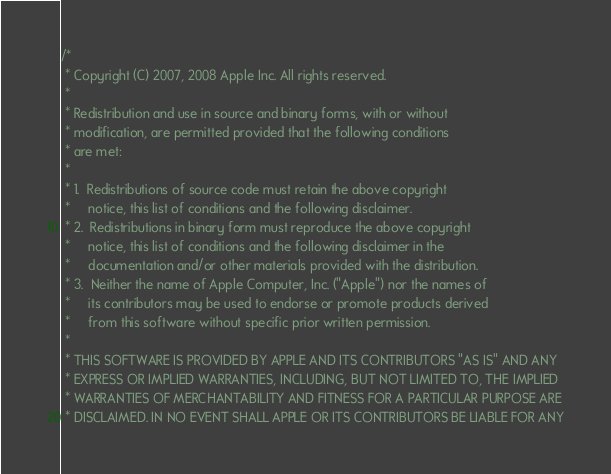<code> <loc_0><loc_0><loc_500><loc_500><_ObjectiveC_>/*
 * Copyright (C) 2007, 2008 Apple Inc. All rights reserved.
 *
 * Redistribution and use in source and binary forms, with or without
 * modification, are permitted provided that the following conditions
 * are met:
 *
 * 1.  Redistributions of source code must retain the above copyright
 *     notice, this list of conditions and the following disclaimer. 
 * 2.  Redistributions in binary form must reproduce the above copyright
 *     notice, this list of conditions and the following disclaimer in the
 *     documentation and/or other materials provided with the distribution. 
 * 3.  Neither the name of Apple Computer, Inc. ("Apple") nor the names of
 *     its contributors may be used to endorse or promote products derived
 *     from this software without specific prior written permission. 
 *
 * THIS SOFTWARE IS PROVIDED BY APPLE AND ITS CONTRIBUTORS "AS IS" AND ANY
 * EXPRESS OR IMPLIED WARRANTIES, INCLUDING, BUT NOT LIMITED TO, THE IMPLIED
 * WARRANTIES OF MERCHANTABILITY AND FITNESS FOR A PARTICULAR PURPOSE ARE
 * DISCLAIMED. IN NO EVENT SHALL APPLE OR ITS CONTRIBUTORS BE LIABLE FOR ANY</code> 